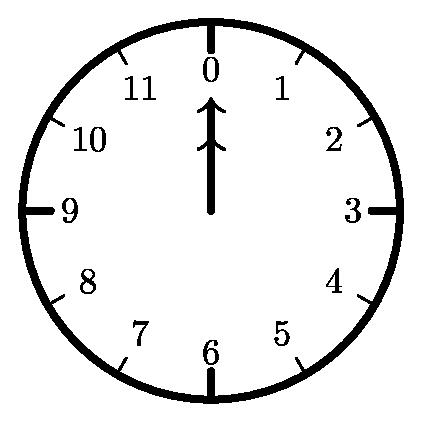Imagine you could design a clock with more than 12 hours on its face. How do you think that would impact the complexity of this problem? Increasing the number of hours on the clock face would exponentially increase the complexity of the problem. With each additional hour, there are more positions for the hands to occupy and more sequences of movements. This means the number of Hamiltonian cycles would also increase, significantly heightening the complexity of calculating all possible unique sequences. Therefore, a clock with more than 12 hours would demand much more computational power to find the value of N. 